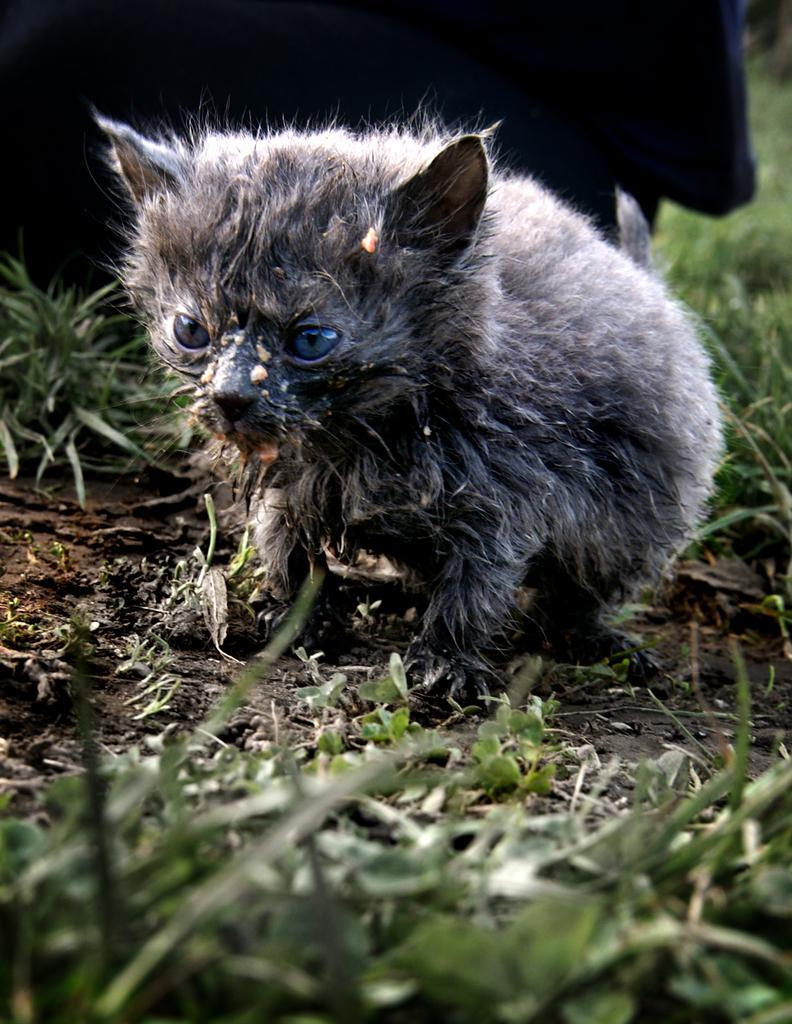Can you describe this image briefly? In this image I can see an animal in black and white color. I can see few green grass and mud. 